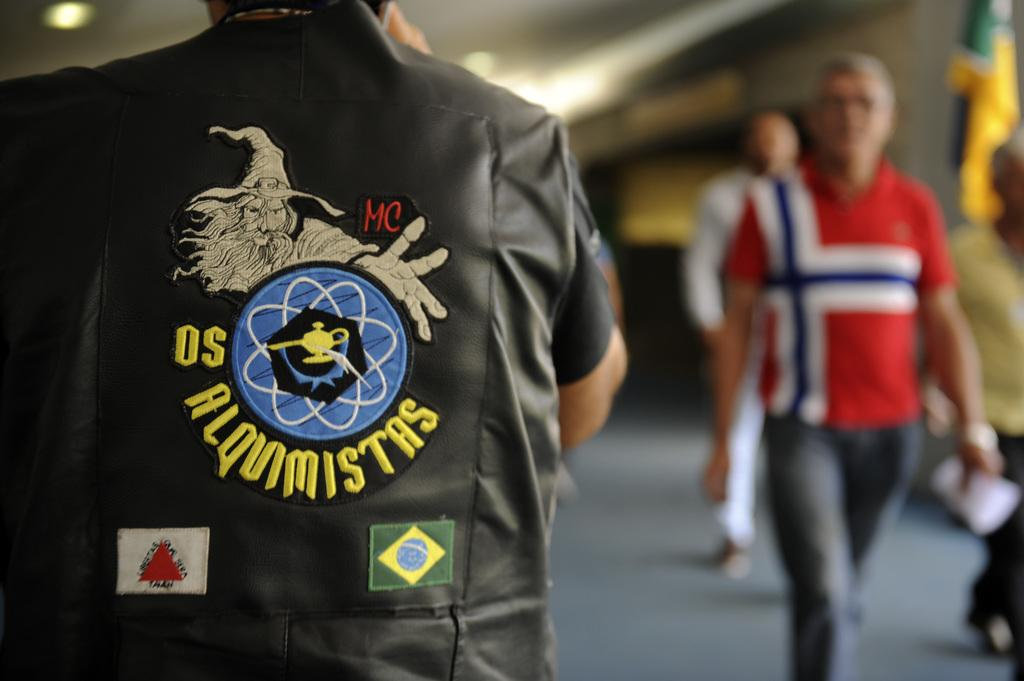<image>
Create a compact narrative representing the image presented. Person wearing a leather vest that says OS on the back. 